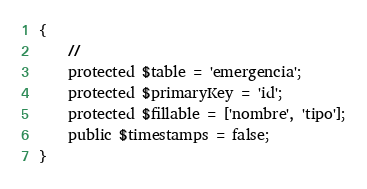Convert code to text. <code><loc_0><loc_0><loc_500><loc_500><_PHP_>{
    //
    protected $table = 'emergencia';
    protected $primaryKey = 'id';
    protected $fillable = ['nombre', 'tipo'];
    public $timestamps = false;
}
</code> 